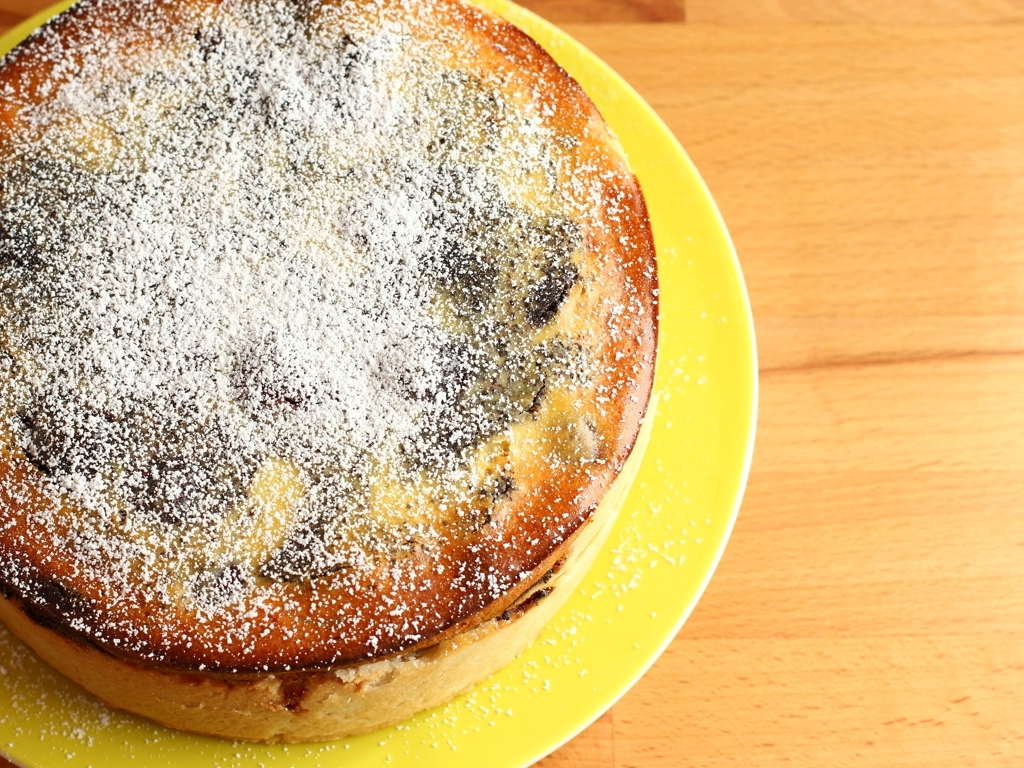Is there anything to indicate if this cake has been made from scratch or bought from a store? The even distribution of powdered sugar and the uniform golden crust suggest attention to detail, which could point to a homemade creation. However, without packaging or other clear indicators in the image, it's not possible to determine with certainty whether the cake is homemade or store-bought. 